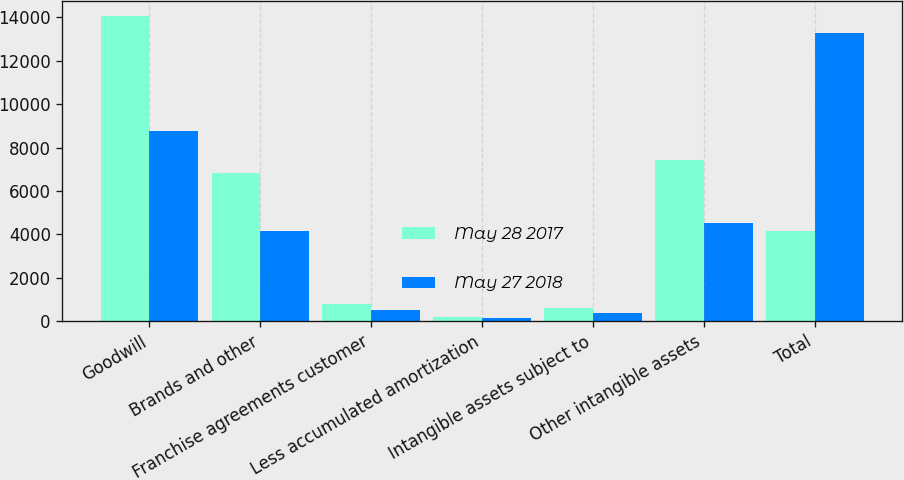Convert chart. <chart><loc_0><loc_0><loc_500><loc_500><stacked_bar_chart><ecel><fcel>Goodwill<fcel>Brands and other<fcel>Franchise agreements customer<fcel>Less accumulated amortization<fcel>Intangible assets subject to<fcel>Other intangible assets<fcel>Total<nl><fcel>May 28 2017<fcel>14065<fcel>6818.7<fcel>811.7<fcel>185.3<fcel>626.4<fcel>7445.1<fcel>4161.1<nl><fcel>May 27 2018<fcel>8747.2<fcel>4161.1<fcel>524.8<fcel>155.5<fcel>369.3<fcel>4530.4<fcel>13277.6<nl></chart> 